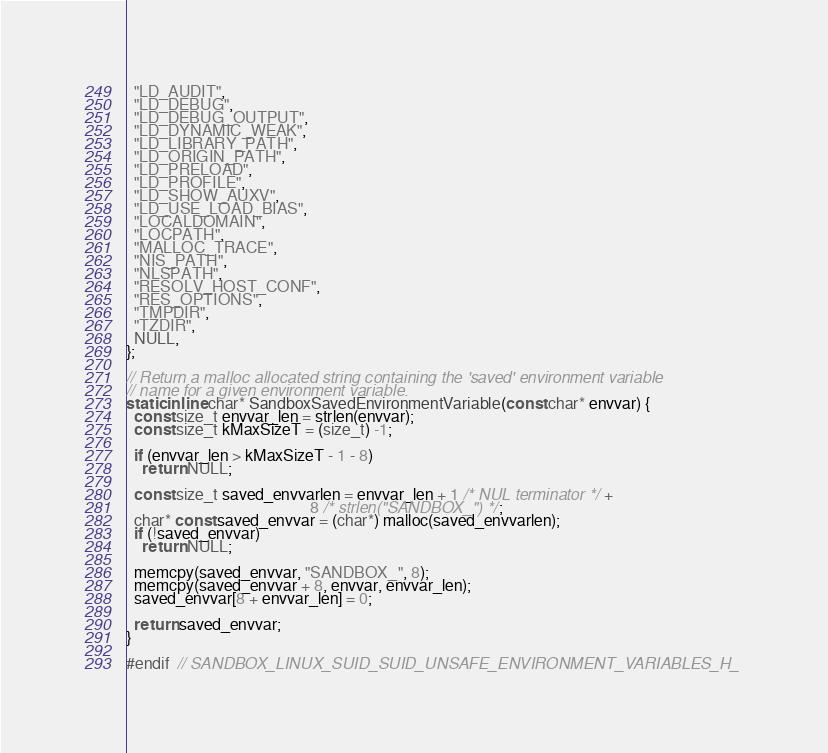<code> <loc_0><loc_0><loc_500><loc_500><_C_>  "LD_AUDIT",
  "LD_DEBUG",
  "LD_DEBUG_OUTPUT",
  "LD_DYNAMIC_WEAK",
  "LD_LIBRARY_PATH",
  "LD_ORIGIN_PATH",
  "LD_PRELOAD",
  "LD_PROFILE",
  "LD_SHOW_AUXV",
  "LD_USE_LOAD_BIAS",
  "LOCALDOMAIN",
  "LOCPATH",
  "MALLOC_TRACE",
  "NIS_PATH",
  "NLSPATH",
  "RESOLV_HOST_CONF",
  "RES_OPTIONS",
  "TMPDIR",
  "TZDIR",
  NULL,
};

// Return a malloc allocated string containing the 'saved' environment variable
// name for a given environment variable.
static inline char* SandboxSavedEnvironmentVariable(const char* envvar) {
  const size_t envvar_len = strlen(envvar);
  const size_t kMaxSizeT = (size_t) -1;

  if (envvar_len > kMaxSizeT - 1 - 8)
    return NULL;

  const size_t saved_envvarlen = envvar_len + 1 /* NUL terminator */ +
                                              8 /* strlen("SANDBOX_") */;
  char* const saved_envvar = (char*) malloc(saved_envvarlen);
  if (!saved_envvar)
    return NULL;

  memcpy(saved_envvar, "SANDBOX_", 8);
  memcpy(saved_envvar + 8, envvar, envvar_len);
  saved_envvar[8 + envvar_len] = 0;

  return saved_envvar;
}

#endif  // SANDBOX_LINUX_SUID_SUID_UNSAFE_ENVIRONMENT_VARIABLES_H_
</code> 